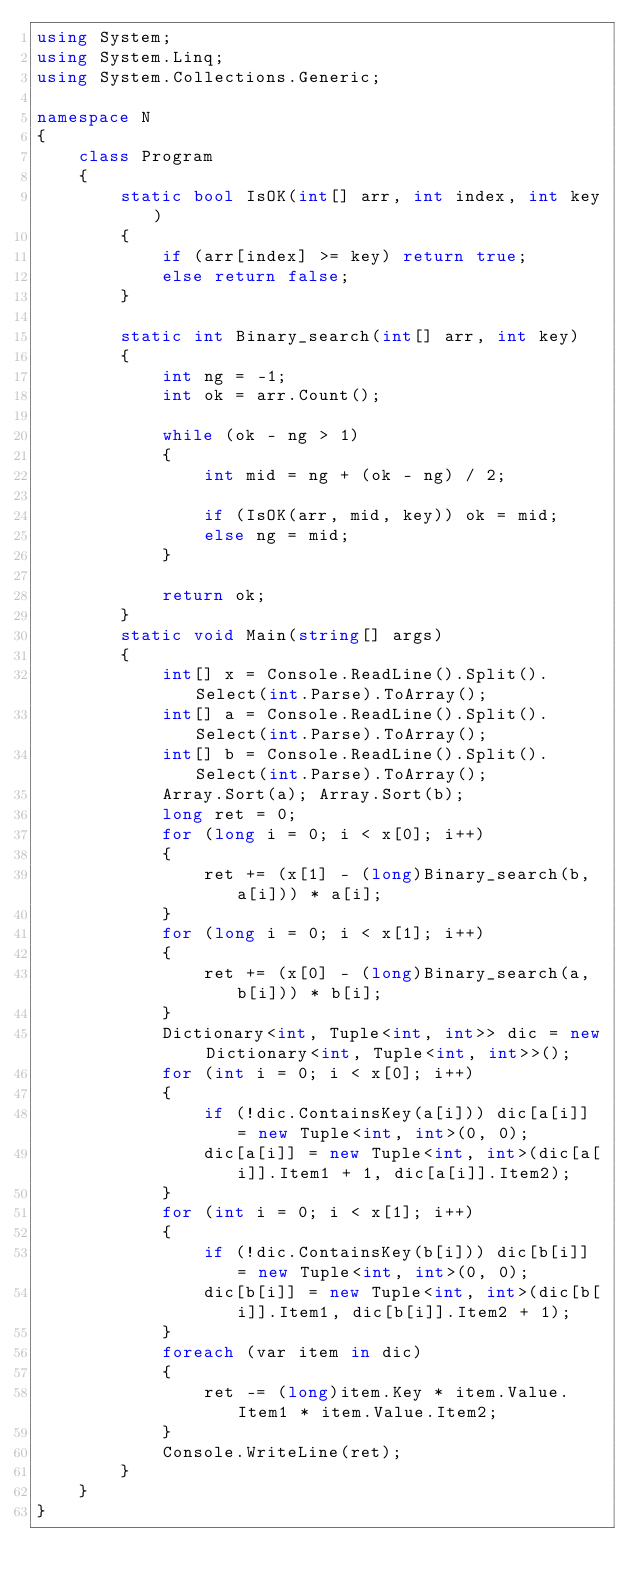Convert code to text. <code><loc_0><loc_0><loc_500><loc_500><_C#_>using System;
using System.Linq;
using System.Collections.Generic;

namespace N
{
    class Program
    {
        static bool IsOK(int[] arr, int index, int key)
        {
            if (arr[index] >= key) return true;
            else return false;
        }

        static int Binary_search(int[] arr, int key)
        {
            int ng = -1;
            int ok = arr.Count();

            while (ok - ng > 1)
            {
                int mid = ng + (ok - ng) / 2;

                if (IsOK(arr, mid, key)) ok = mid;
                else ng = mid;
            }

            return ok;
        }
        static void Main(string[] args)
        {
            int[] x = Console.ReadLine().Split().Select(int.Parse).ToArray();
            int[] a = Console.ReadLine().Split().Select(int.Parse).ToArray();
            int[] b = Console.ReadLine().Split().Select(int.Parse).ToArray();
            Array.Sort(a); Array.Sort(b);
            long ret = 0;
            for (long i = 0; i < x[0]; i++)
            {
                ret += (x[1] - (long)Binary_search(b, a[i])) * a[i];
            }
            for (long i = 0; i < x[1]; i++)
            {
                ret += (x[0] - (long)Binary_search(a, b[i])) * b[i];
            }
            Dictionary<int, Tuple<int, int>> dic = new Dictionary<int, Tuple<int, int>>();
            for (int i = 0; i < x[0]; i++)
            {
                if (!dic.ContainsKey(a[i])) dic[a[i]] = new Tuple<int, int>(0, 0);
                dic[a[i]] = new Tuple<int, int>(dic[a[i]].Item1 + 1, dic[a[i]].Item2);
            }
            for (int i = 0; i < x[1]; i++)
            {
                if (!dic.ContainsKey(b[i])) dic[b[i]] = new Tuple<int, int>(0, 0);
                dic[b[i]] = new Tuple<int, int>(dic[b[i]].Item1, dic[b[i]].Item2 + 1);
            }
            foreach (var item in dic)
            {
                ret -= (long)item.Key * item.Value.Item1 * item.Value.Item2;
            }
            Console.WriteLine(ret);
        }
    }
}
</code> 